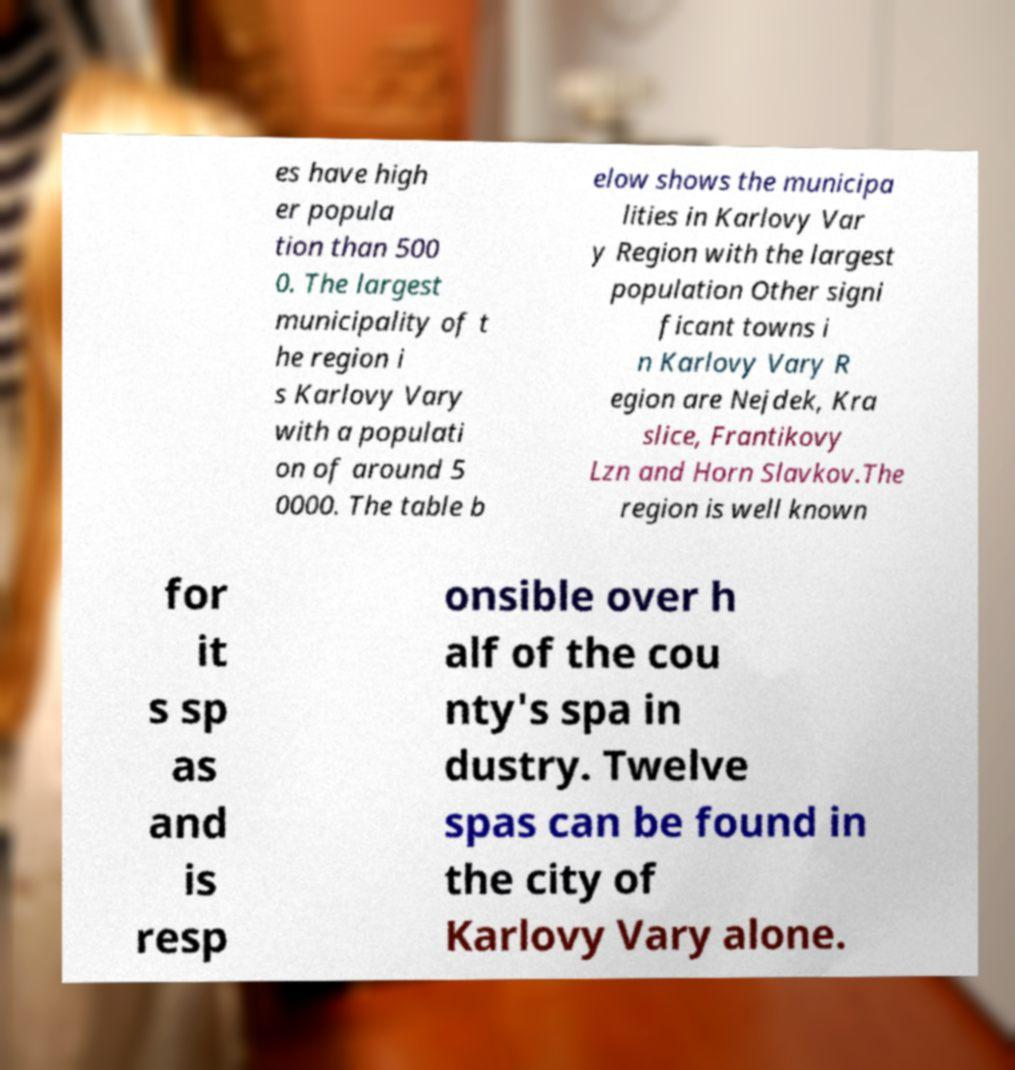Can you accurately transcribe the text from the provided image for me? es have high er popula tion than 500 0. The largest municipality of t he region i s Karlovy Vary with a populati on of around 5 0000. The table b elow shows the municipa lities in Karlovy Var y Region with the largest population Other signi ficant towns i n Karlovy Vary R egion are Nejdek, Kra slice, Frantikovy Lzn and Horn Slavkov.The region is well known for it s sp as and is resp onsible over h alf of the cou nty's spa in dustry. Twelve spas can be found in the city of Karlovy Vary alone. 